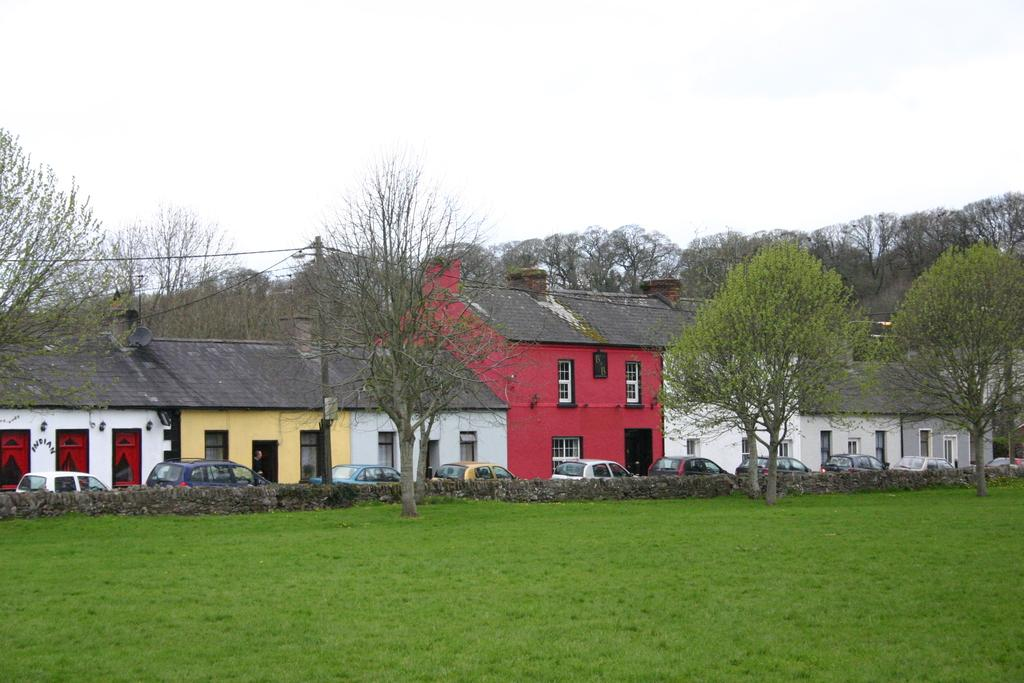What type of structures can be seen in the image? There are houses in the image. What vehicles are present in the image? There are cars in the image. What type of vegetation is visible in the image? There is green grass in the image. What architectural feature can be seen in the image? There is a wall in the image. What other natural elements are present in the image? There are trees in the image. What man-made objects can be seen in the image? There is a pole in the image, and there are wires attached to it. What is visible in the background of the image? The sky is visible in the background of the image. What type of dress is hanging on the pole in the image? There is no dress present in the image; the pole has wires attached to it. What type of acoustics can be heard from the trees in the image? There is no sound or acoustics mentioned in the image, and the trees are not described as producing any sounds. 